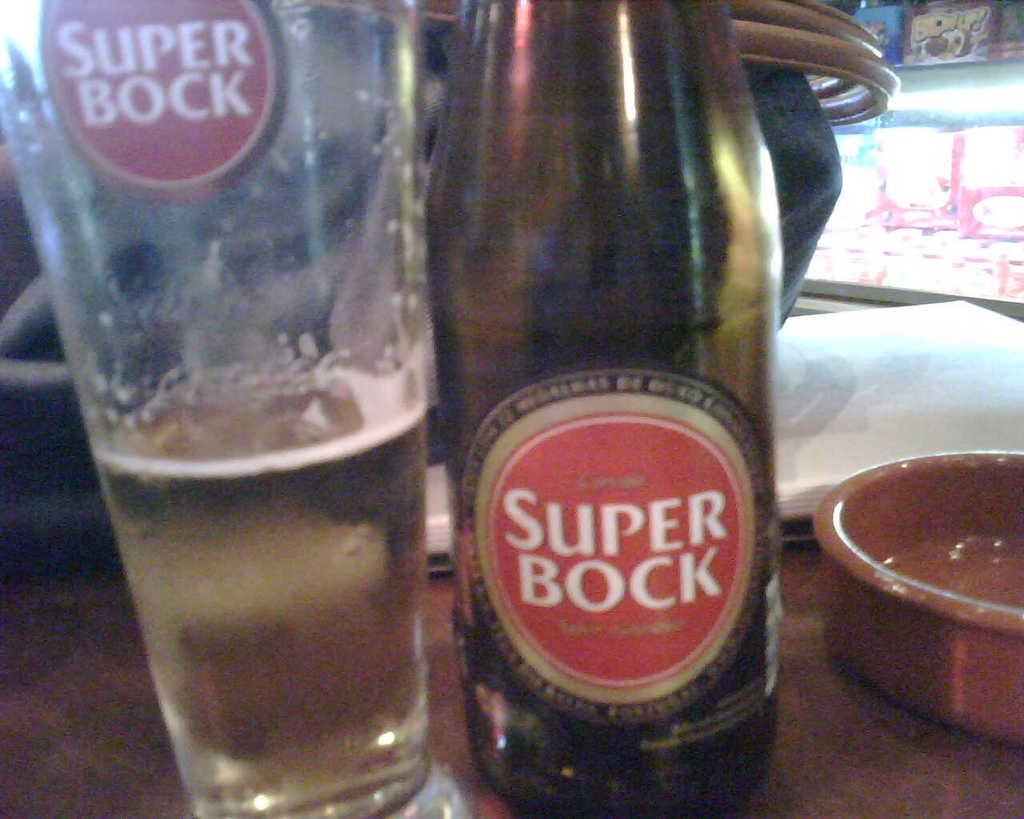What kind of beer is this?
Provide a short and direct response. Super bock. 